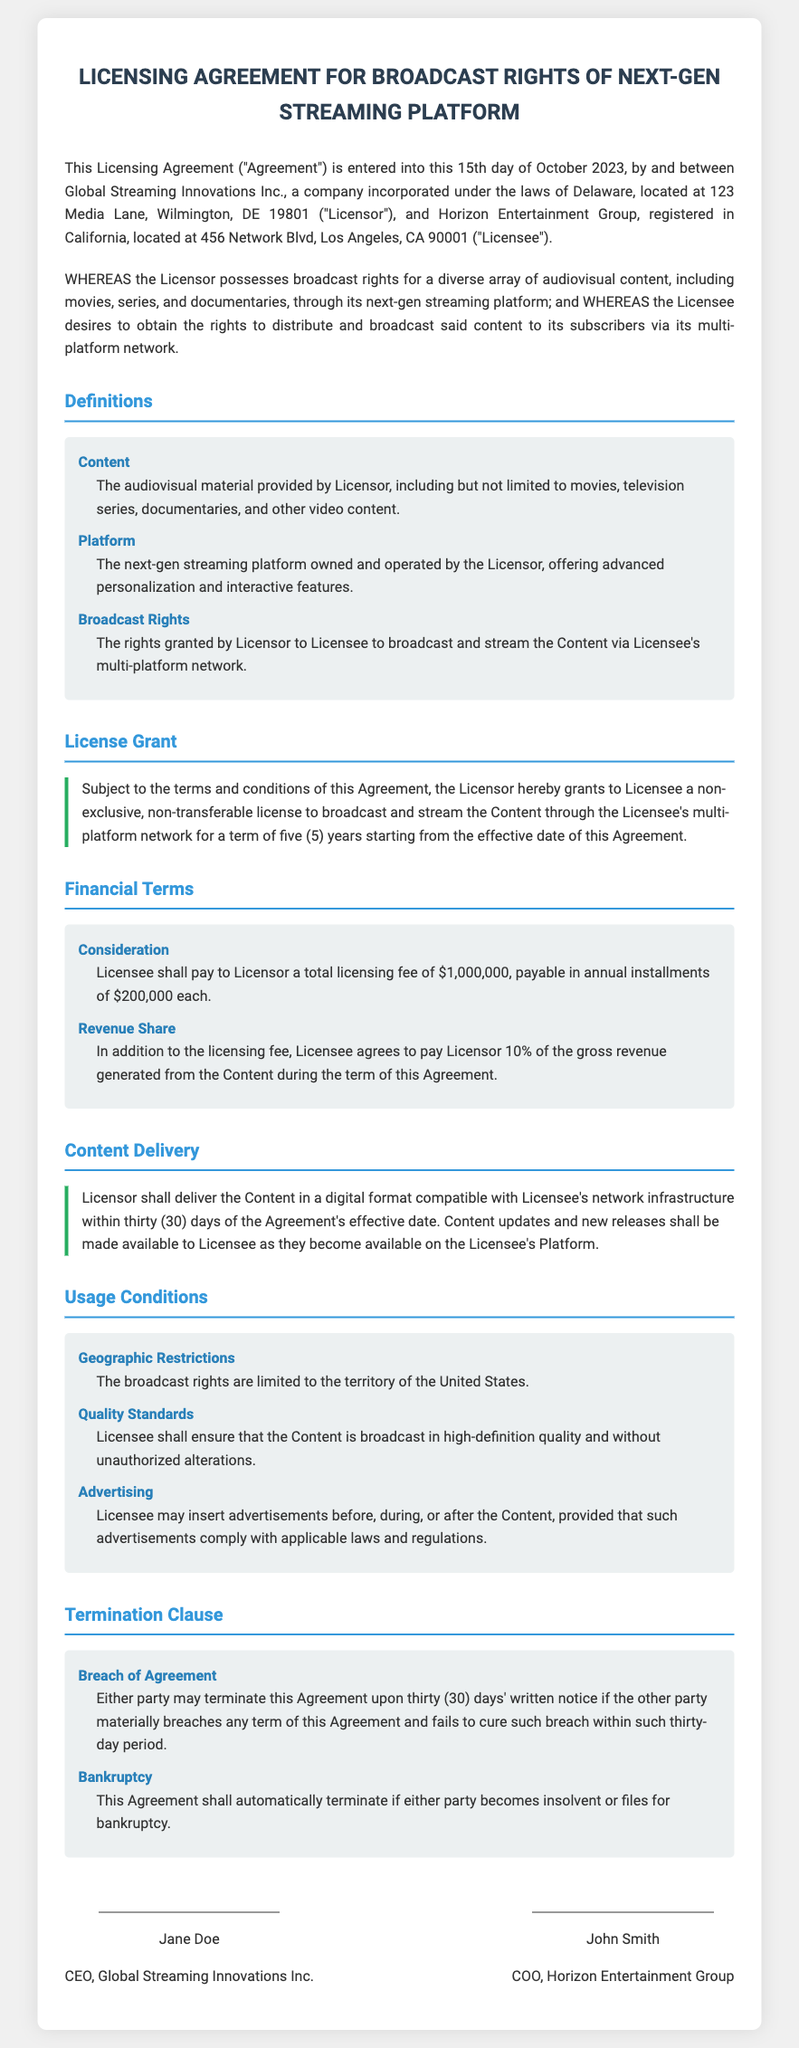What is the date of the Agreement? The Agreement is entered into on the 15th day of October 2023.
Answer: 15th day of October 2023 Who are the parties involved in the Agreement? The Licensor is Global Streaming Innovations Inc., and the Licensee is Horizon Entertainment Group.
Answer: Global Streaming Innovations Inc. and Horizon Entertainment Group What is the total licensing fee? The total licensing fee stated in the document is $1,000,000.
Answer: $1,000,000 What is the duration of the license? The license is granted for a term of five years starting from the effective date.
Answer: Five years What are the geographic restrictions for the broadcast rights? The broadcast rights are limited to the territory of the United States.
Answer: The United States What percentage of gross revenue must Licensee pay to Licensor? Licensee agrees to pay Licensor 10% of the gross revenue generated from the Content.
Answer: 10% What is required from Licensee regarding the quality of broadcast? Licensee must ensure that the Content is broadcast in high-definition quality.
Answer: High-definition quality What triggers automatic termination of the Agreement? The Agreement shall automatically terminate if either party becomes insolvent or files for bankruptcy.
Answer: Insolvency or bankruptcy What is required for either party to terminate the Agreement? Either party may terminate the Agreement upon thirty days' written notice of material breach.
Answer: Thirty days' written notice 